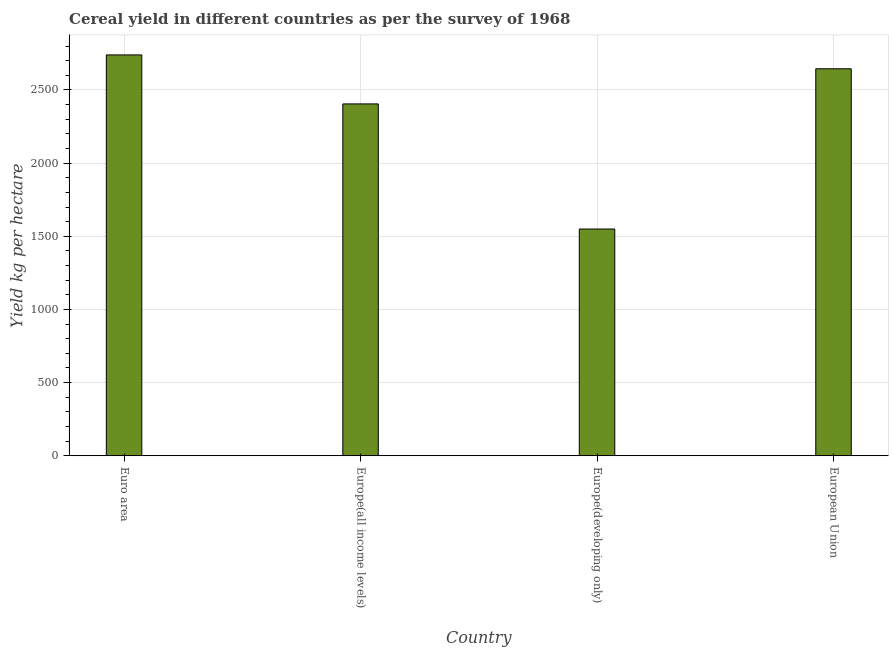Does the graph contain grids?
Provide a short and direct response. Yes. What is the title of the graph?
Provide a short and direct response. Cereal yield in different countries as per the survey of 1968. What is the label or title of the X-axis?
Your answer should be compact. Country. What is the label or title of the Y-axis?
Your response must be concise. Yield kg per hectare. What is the cereal yield in Euro area?
Your answer should be very brief. 2739.59. Across all countries, what is the maximum cereal yield?
Offer a terse response. 2739.59. Across all countries, what is the minimum cereal yield?
Offer a terse response. 1549.55. In which country was the cereal yield minimum?
Provide a succinct answer. Europe(developing only). What is the sum of the cereal yield?
Make the answer very short. 9338.63. What is the difference between the cereal yield in Euro area and Europe(all income levels)?
Give a very brief answer. 334.93. What is the average cereal yield per country?
Give a very brief answer. 2334.66. What is the median cereal yield?
Your answer should be very brief. 2524.75. In how many countries, is the cereal yield greater than 900 kg per hectare?
Provide a succinct answer. 4. What is the ratio of the cereal yield in Euro area to that in Europe(all income levels)?
Keep it short and to the point. 1.14. Is the cereal yield in Europe(developing only) less than that in European Union?
Provide a succinct answer. Yes. What is the difference between the highest and the second highest cereal yield?
Make the answer very short. 94.75. Is the sum of the cereal yield in Euro area and Europe(all income levels) greater than the maximum cereal yield across all countries?
Make the answer very short. Yes. What is the difference between the highest and the lowest cereal yield?
Provide a succinct answer. 1190.04. How many bars are there?
Offer a very short reply. 4. What is the difference between two consecutive major ticks on the Y-axis?
Offer a terse response. 500. What is the Yield kg per hectare of Euro area?
Offer a very short reply. 2739.59. What is the Yield kg per hectare in Europe(all income levels)?
Your response must be concise. 2404.66. What is the Yield kg per hectare in Europe(developing only)?
Offer a terse response. 1549.55. What is the Yield kg per hectare of European Union?
Your answer should be compact. 2644.83. What is the difference between the Yield kg per hectare in Euro area and Europe(all income levels)?
Your response must be concise. 334.93. What is the difference between the Yield kg per hectare in Euro area and Europe(developing only)?
Your response must be concise. 1190.04. What is the difference between the Yield kg per hectare in Euro area and European Union?
Your answer should be compact. 94.75. What is the difference between the Yield kg per hectare in Europe(all income levels) and Europe(developing only)?
Keep it short and to the point. 855.12. What is the difference between the Yield kg per hectare in Europe(all income levels) and European Union?
Your answer should be compact. -240.17. What is the difference between the Yield kg per hectare in Europe(developing only) and European Union?
Give a very brief answer. -1095.29. What is the ratio of the Yield kg per hectare in Euro area to that in Europe(all income levels)?
Make the answer very short. 1.14. What is the ratio of the Yield kg per hectare in Euro area to that in Europe(developing only)?
Your response must be concise. 1.77. What is the ratio of the Yield kg per hectare in Euro area to that in European Union?
Provide a succinct answer. 1.04. What is the ratio of the Yield kg per hectare in Europe(all income levels) to that in Europe(developing only)?
Your response must be concise. 1.55. What is the ratio of the Yield kg per hectare in Europe(all income levels) to that in European Union?
Offer a terse response. 0.91. What is the ratio of the Yield kg per hectare in Europe(developing only) to that in European Union?
Make the answer very short. 0.59. 